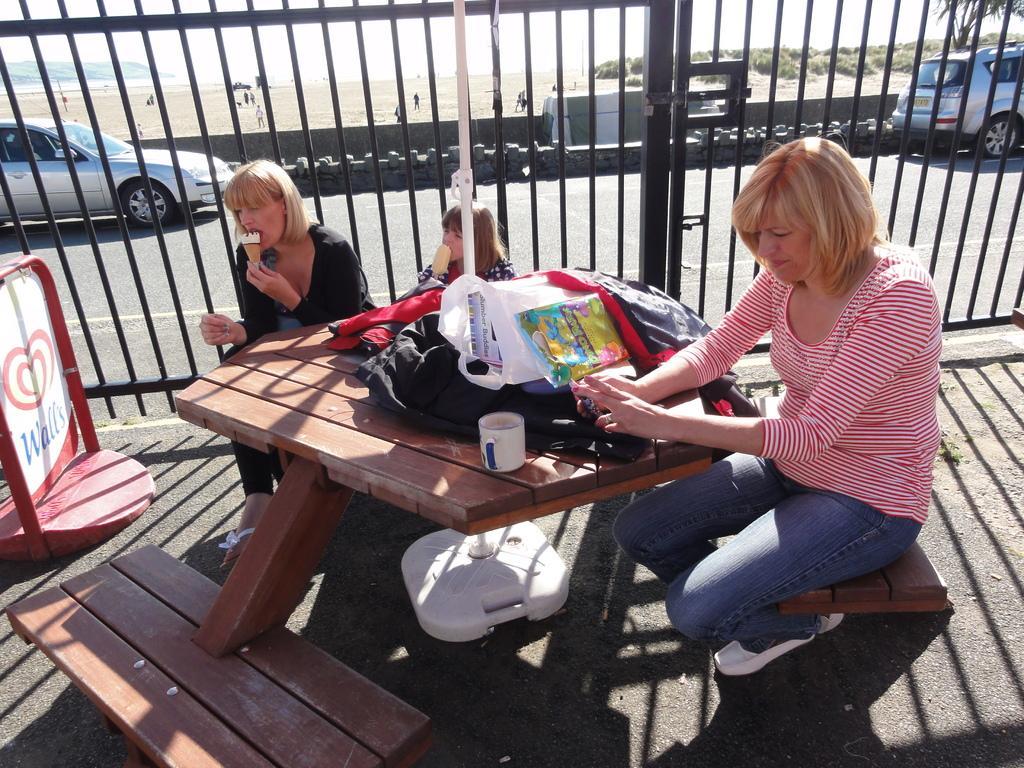Can you describe this image briefly? There is a table attached chair. On this table there are some wrappers, bag, cup. One lady is sitting on the chair. And a girl sitting near the table is eating ice cream. And a lady wearing black dress is also eating ice cream. There is a sign board. Behind them there is a grill and road and vehicles are passing on this road. 